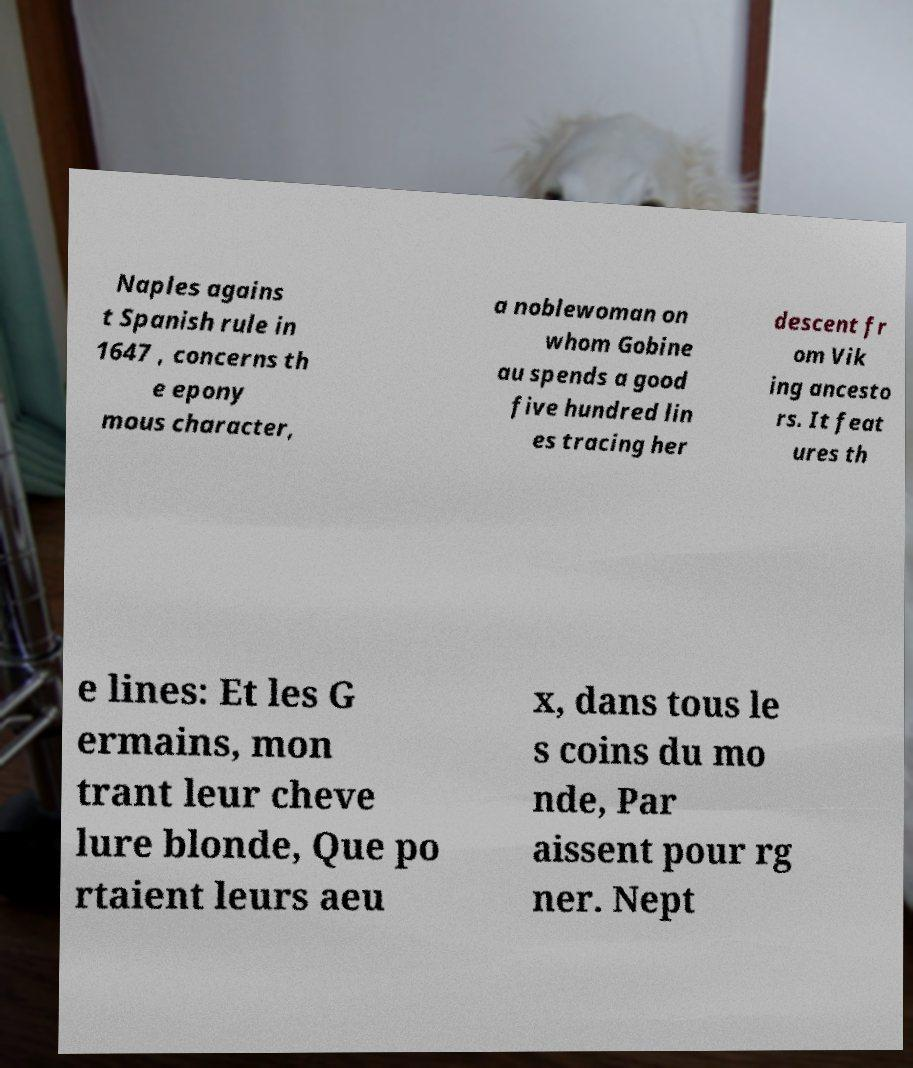Could you assist in decoding the text presented in this image and type it out clearly? Naples agains t Spanish rule in 1647 , concerns th e epony mous character, a noblewoman on whom Gobine au spends a good five hundred lin es tracing her descent fr om Vik ing ancesto rs. It feat ures th e lines: Et les G ermains, mon trant leur cheve lure blonde, Que po rtaient leurs aeu x, dans tous le s coins du mo nde, Par aissent pour rg ner. Nept 